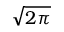Convert formula to latex. <formula><loc_0><loc_0><loc_500><loc_500>\sqrt { 2 \pi }</formula> 